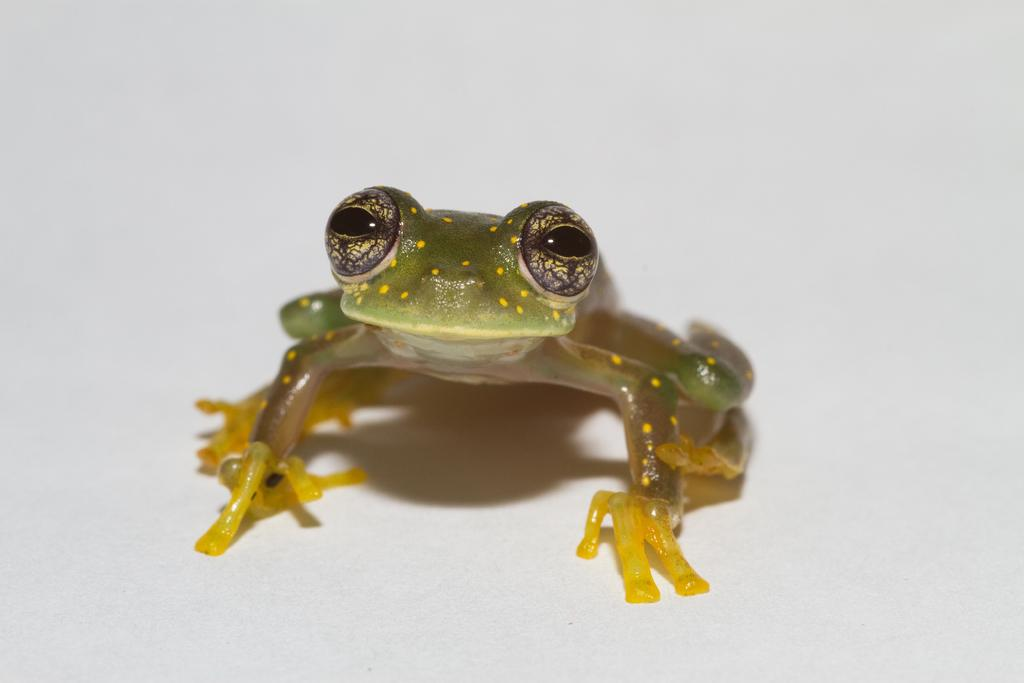What is the main subject of the image? There is a frog in the image. What color is the background of the image? The background of the image is white. How does the frog manage to burn itself in the image? There is no indication in the image that the frog is burning or in any danger of burning. 